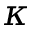Convert formula to latex. <formula><loc_0><loc_0><loc_500><loc_500>\kappa</formula> 